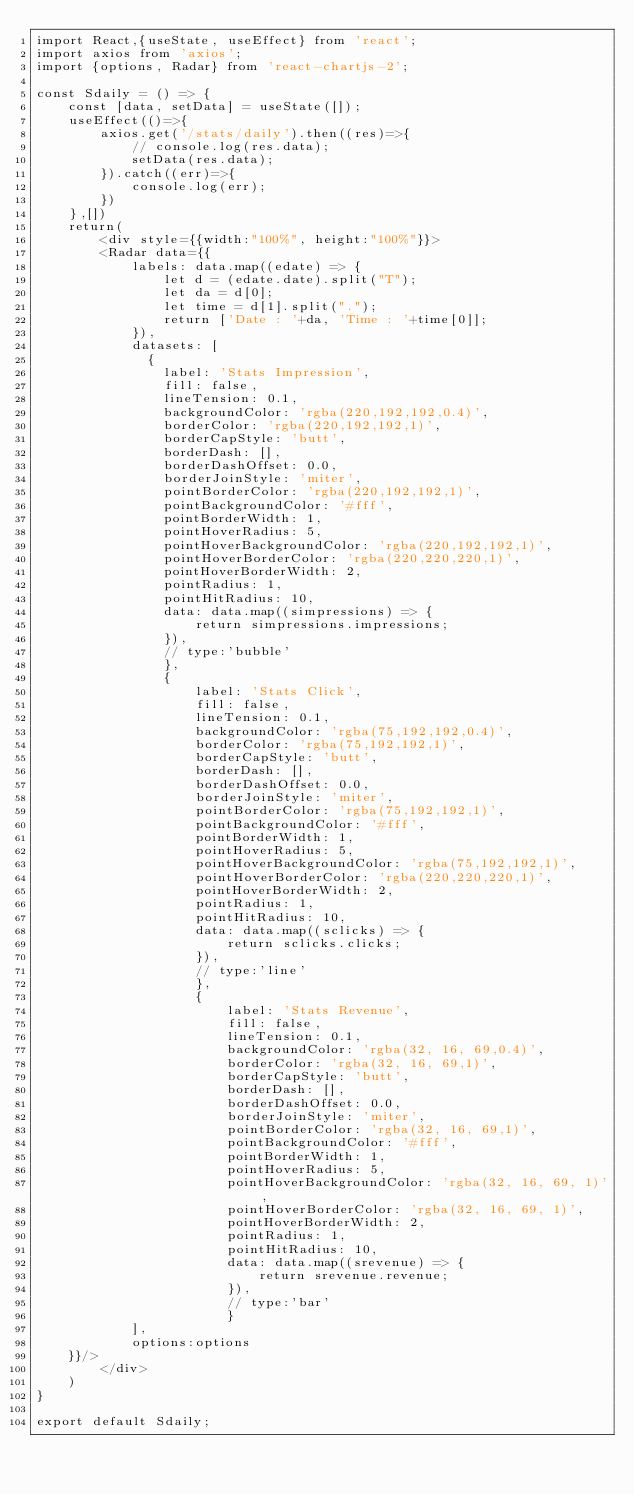Convert code to text. <code><loc_0><loc_0><loc_500><loc_500><_JavaScript_>import React,{useState, useEffect} from 'react';
import axios from 'axios';
import {options, Radar} from 'react-chartjs-2';

const Sdaily = () => {
    const [data, setData] = useState([]);
    useEffect(()=>{
        axios.get('/stats/daily').then((res)=>{
            // console.log(res.data);
            setData(res.data);
        }).catch((err)=>{
            console.log(err);
        })
    },[])
    return(
        <div style={{width:"100%", height:"100%"}}>
        <Radar data={{
            labels: data.map((edate) => {
                let d = (edate.date).split("T");
                let da = d[0];
                let time = d[1].split(".");
                return ['Date : '+da, 'Time : '+time[0]];
            }),
            datasets: [
              {
                label: 'Stats Impression',
                fill: false,
                lineTension: 0.1,
                backgroundColor: 'rgba(220,192,192,0.4)',
                borderColor: 'rgba(220,192,192,1)',
                borderCapStyle: 'butt',
                borderDash: [],
                borderDashOffset: 0.0,
                borderJoinStyle: 'miter',
                pointBorderColor: 'rgba(220,192,192,1)',
                pointBackgroundColor: '#fff',
                pointBorderWidth: 1,
                pointHoverRadius: 5,
                pointHoverBackgroundColor: 'rgba(220,192,192,1)',
                pointHoverBorderColor: 'rgba(220,220,220,1)',
                pointHoverBorderWidth: 2,
                pointRadius: 1,
                pointHitRadius: 10,
                data: data.map((simpressions) => {
                    return simpressions.impressions;
                }),
                // type:'bubble'
                },
                {
                    label: 'Stats Click',
                    fill: false,
                    lineTension: 0.1,
                    backgroundColor: 'rgba(75,192,192,0.4)',
                    borderColor: 'rgba(75,192,192,1)',
                    borderCapStyle: 'butt',
                    borderDash: [],
                    borderDashOffset: 0.0,
                    borderJoinStyle: 'miter',
                    pointBorderColor: 'rgba(75,192,192,1)',
                    pointBackgroundColor: '#fff',
                    pointBorderWidth: 1,
                    pointHoverRadius: 5,
                    pointHoverBackgroundColor: 'rgba(75,192,192,1)',
                    pointHoverBorderColor: 'rgba(220,220,220,1)',
                    pointHoverBorderWidth: 2,
                    pointRadius: 1,
                    pointHitRadius: 10,
                    data: data.map((sclicks) => {
                        return sclicks.clicks;
                    }),
                    // type:'line'
                    },
                    {
                        label: 'Stats Revenue',
                        fill: false,
                        lineTension: 0.1,
                        backgroundColor: 'rgba(32, 16, 69,0.4)',
                        borderColor: 'rgba(32, 16, 69,1)',
                        borderCapStyle: 'butt',
                        borderDash: [],
                        borderDashOffset: 0.0,
                        borderJoinStyle: 'miter',
                        pointBorderColor: 'rgba(32, 16, 69,1)',
                        pointBackgroundColor: '#fff',
                        pointBorderWidth: 1,
                        pointHoverRadius: 5,
                        pointHoverBackgroundColor: 'rgba(32, 16, 69, 1)',
                        pointHoverBorderColor: 'rgba(32, 16, 69, 1)',
                        pointHoverBorderWidth: 2,
                        pointRadius: 1,
                        pointHitRadius: 10,
                        data: data.map((srevenue) => {
                            return srevenue.revenue;
                        }),
                        // type:'bar'
                        }                                      
            ],
            options:options
    }}/>
        </div>
    )
}

export default Sdaily;</code> 